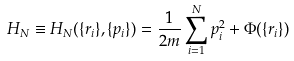<formula> <loc_0><loc_0><loc_500><loc_500>H _ { N } \equiv H _ { N } ( \{ r _ { i } \} , \{ p _ { i } \} ) = \frac { 1 } { 2 m } \sum _ { i = 1 } ^ { N } p _ { i } ^ { 2 } + \Phi ( \{ r _ { i } \} )</formula> 